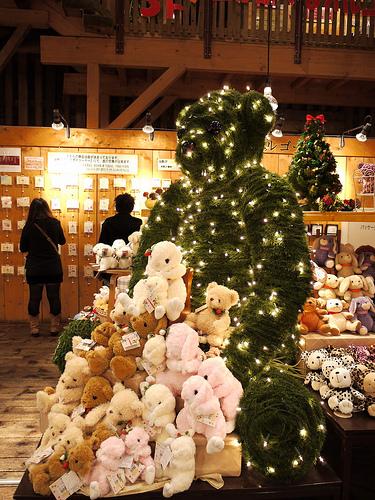Is it Christmas?
Keep it brief. Yes. Are the pink stuffed animals lambs?
Quick response, please. No. What are the people looking at on the wall in the background?
Keep it brief. Pictures. What store are these bears from?
Be succinct. Christmas store. 